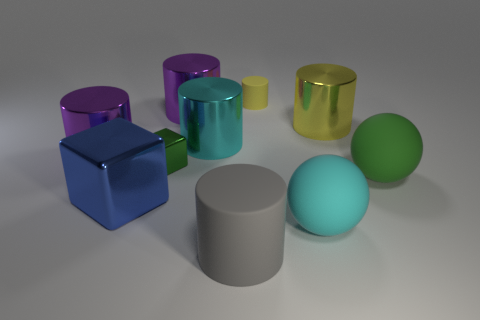What number of objects are brown metal objects or yellow shiny things behind the green rubber ball?
Your answer should be very brief. 1. What is the size of the cylinder that is in front of the cyan metal object and on the right side of the green metallic object?
Your answer should be very brief. Large. Is the number of cylinders in front of the large yellow metallic cylinder greater than the number of large rubber things in front of the blue metallic object?
Offer a terse response. Yes. Is the shape of the big blue object the same as the small yellow object to the left of the green rubber sphere?
Make the answer very short. No. How many other things are the same shape as the big cyan shiny thing?
Offer a terse response. 5. There is a big object that is both in front of the blue shiny thing and to the left of the tiny matte object; what is its color?
Offer a terse response. Gray. What color is the small cylinder?
Your answer should be very brief. Yellow. Do the gray cylinder and the cylinder that is to the right of the tiny matte cylinder have the same material?
Your answer should be compact. No. There is a cyan thing that is made of the same material as the tiny cylinder; what is its shape?
Provide a succinct answer. Sphere. What color is the shiny cube that is the same size as the cyan cylinder?
Provide a short and direct response. Blue. 